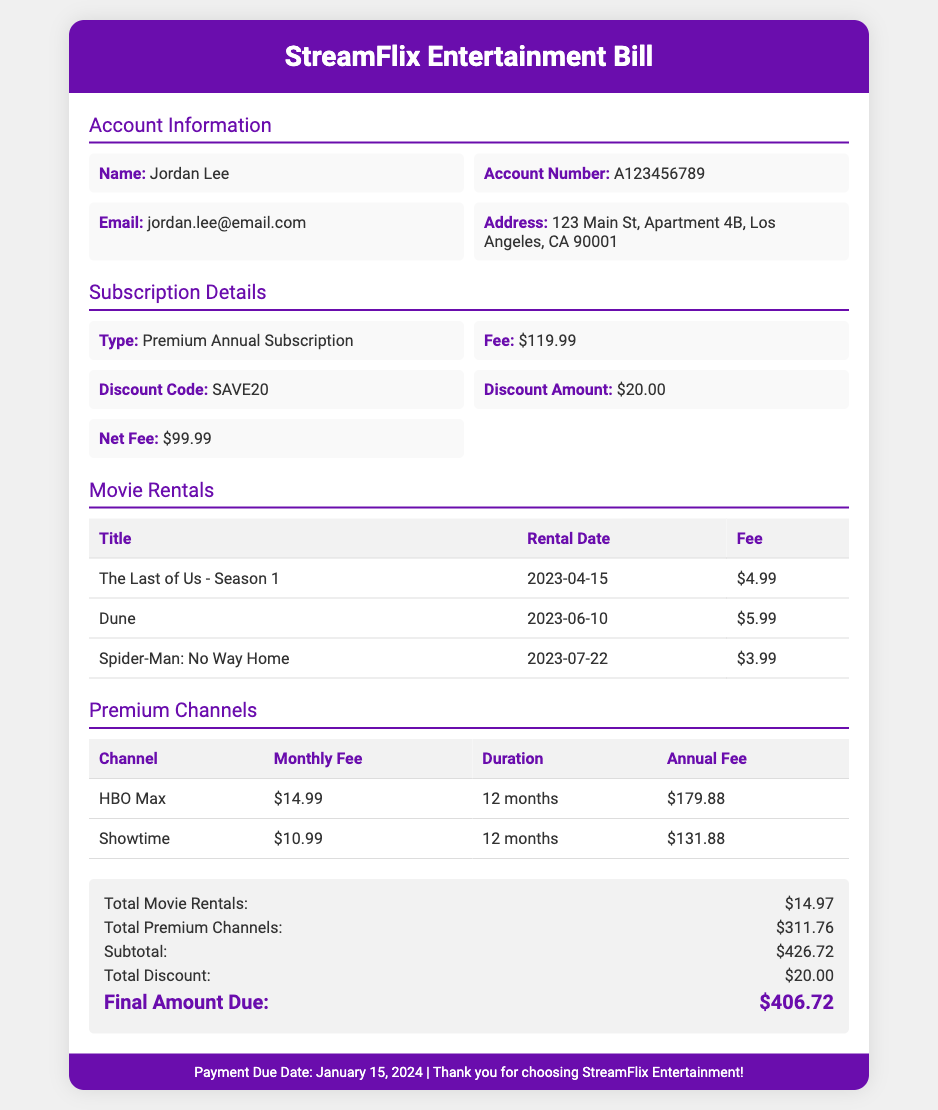What is the name on the account? The document provides the name associated with the account, which is Jordan Lee.
Answer: Jordan Lee What is the annual subscription fee? The annual subscription fee is listed in the Subscription Details section as $119.99.
Answer: $119.99 How much was the discount applied? The discount amount is specified in the document under Subscription Details as $20.00.
Answer: $20.00 What is the title of the first movie rented? The first title listed under Movie Rentals is "The Last of Us - Season 1."
Answer: The Last of Us - Season 1 What is the total fee for premium channels? The document summarizes the annual fee for all premium channels as $311.76.
Answer: $311.76 How many months are covered for HBO Max? The document states that HBO Max lasts for 12 months in the Premium Channels section.
Answer: 12 months What is the net fee after applying the discount? Under Subscription Details, the net fee after the discount is calculated and displayed as $99.99.
Answer: $99.99 What is the payment due date? The payment due date is noted in the footer of the document as January 15, 2024.
Answer: January 15, 2024 What is the final amount due? The final amount due is calculated at the end of the total section as $406.72.
Answer: $406.72 